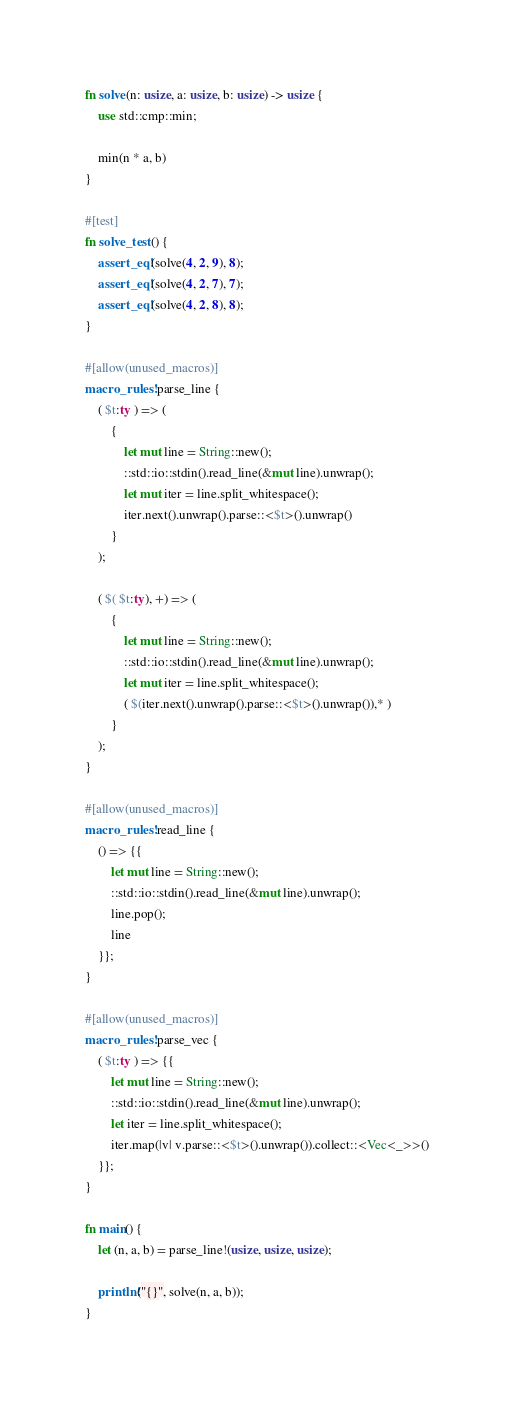Convert code to text. <code><loc_0><loc_0><loc_500><loc_500><_Rust_>fn solve(n: usize, a: usize, b: usize) -> usize {
    use std::cmp::min;

    min(n * a, b)
}

#[test]
fn solve_test() {
    assert_eq!(solve(4, 2, 9), 8);
    assert_eq!(solve(4, 2, 7), 7);
    assert_eq!(solve(4, 2, 8), 8);
}

#[allow(unused_macros)]
macro_rules! parse_line {
    ( $t:ty ) => (
        {
            let mut line = String::new();
            ::std::io::stdin().read_line(&mut line).unwrap();
            let mut iter = line.split_whitespace();
            iter.next().unwrap().parse::<$t>().unwrap()
        }
    );

    ( $( $t:ty), +) => (
        {
            let mut line = String::new();
            ::std::io::stdin().read_line(&mut line).unwrap();
            let mut iter = line.split_whitespace();
            ( $(iter.next().unwrap().parse::<$t>().unwrap()),* )
        }
    );
}

#[allow(unused_macros)]
macro_rules! read_line {
    () => {{
        let mut line = String::new();
        ::std::io::stdin().read_line(&mut line).unwrap();
        line.pop();
        line
    }};
}

#[allow(unused_macros)]
macro_rules! parse_vec {
    ( $t:ty ) => {{
        let mut line = String::new();
        ::std::io::stdin().read_line(&mut line).unwrap();
        let iter = line.split_whitespace();
        iter.map(|v| v.parse::<$t>().unwrap()).collect::<Vec<_>>()
    }};
}

fn main() {
    let (n, a, b) = parse_line!(usize, usize, usize);

    println!("{}", solve(n, a, b));
}
</code> 